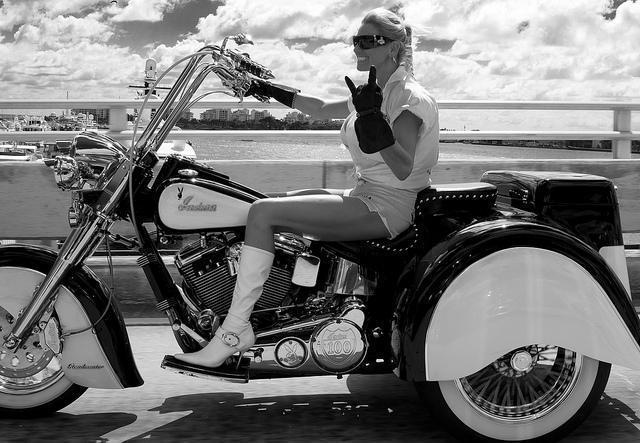How many fingers is she holding up?
Give a very brief answer. 2. How many motorcycles are visible?
Give a very brief answer. 1. 